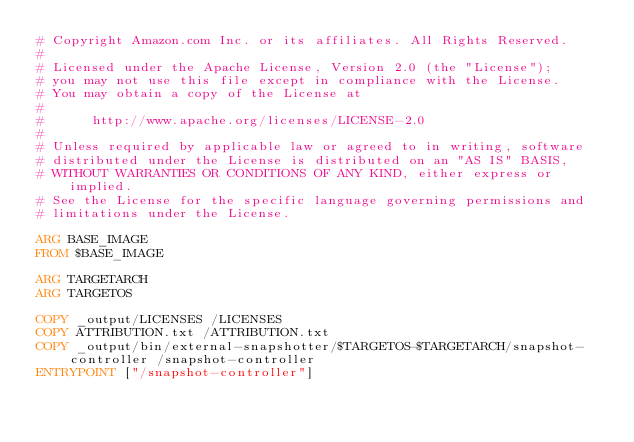<code> <loc_0><loc_0><loc_500><loc_500><_Dockerfile_># Copyright Amazon.com Inc. or its affiliates. All Rights Reserved.
#
# Licensed under the Apache License, Version 2.0 (the "License");
# you may not use this file except in compliance with the License.
# You may obtain a copy of the License at
#
#      http://www.apache.org/licenses/LICENSE-2.0
#
# Unless required by applicable law or agreed to in writing, software
# distributed under the License is distributed on an "AS IS" BASIS,
# WITHOUT WARRANTIES OR CONDITIONS OF ANY KIND, either express or implied.
# See the License for the specific language governing permissions and
# limitations under the License.

ARG BASE_IMAGE
FROM $BASE_IMAGE

ARG TARGETARCH
ARG TARGETOS

COPY _output/LICENSES /LICENSES
COPY ATTRIBUTION.txt /ATTRIBUTION.txt
COPY _output/bin/external-snapshotter/$TARGETOS-$TARGETARCH/snapshot-controller /snapshot-controller
ENTRYPOINT ["/snapshot-controller"]
</code> 